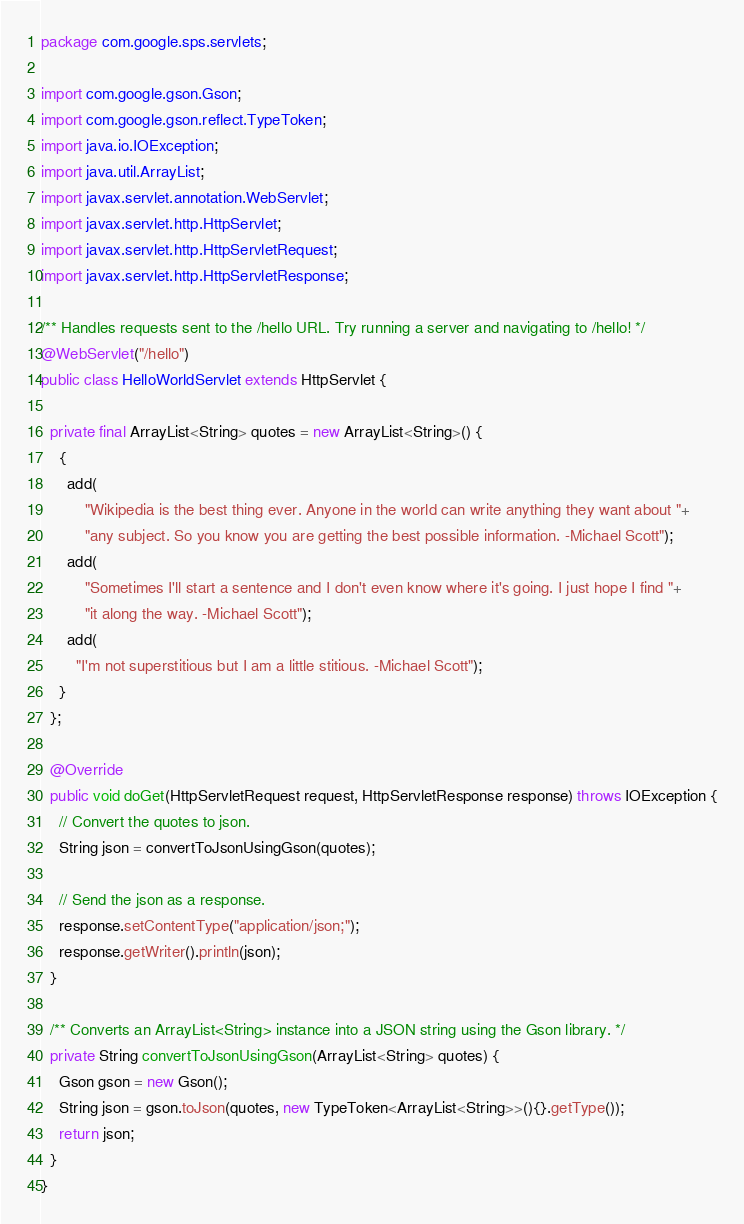<code> <loc_0><loc_0><loc_500><loc_500><_Java_>package com.google.sps.servlets;

import com.google.gson.Gson;
import com.google.gson.reflect.TypeToken;
import java.io.IOException;
import java.util.ArrayList;
import javax.servlet.annotation.WebServlet;
import javax.servlet.http.HttpServlet;
import javax.servlet.http.HttpServletRequest;
import javax.servlet.http.HttpServletResponse;

/** Handles requests sent to the /hello URL. Try running a server and navigating to /hello! */
@WebServlet("/hello")
public class HelloWorldServlet extends HttpServlet {

  private final ArrayList<String> quotes = new ArrayList<String>() {
    {
      add(
          "Wikipedia is the best thing ever. Anyone in the world can write anything they want about "+
          "any subject. So you know you are getting the best possible information. -Michael Scott");
      add(
          "Sometimes I'll start a sentence and I don't even know where it's going. I just hope I find "+
          "it along the way. -Michael Scott");
      add(
        "I'm not superstitious but I am a little stitious. -Michael Scott");
    }
  };

  @Override
  public void doGet(HttpServletRequest request, HttpServletResponse response) throws IOException {
    // Convert the quotes to json.
    String json = convertToJsonUsingGson(quotes);

    // Send the json as a response.
    response.setContentType("application/json;");
    response.getWriter().println(json);
  }

  /** Converts an ArrayList<String> instance into a JSON string using the Gson library. */
  private String convertToJsonUsingGson(ArrayList<String> quotes) {
    Gson gson = new Gson(); 
    String json = gson.toJson(quotes, new TypeToken<ArrayList<String>>(){}.getType());
    return json;
  }
}
</code> 